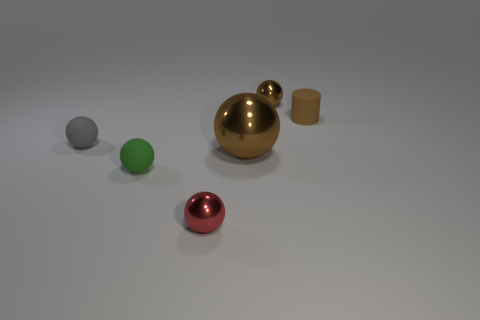Is the color of the rubber cylinder the same as the big metal sphere?
Provide a short and direct response. Yes. Is there a rubber sphere of the same color as the matte cylinder?
Give a very brief answer. No. The matte cylinder that is the same size as the red ball is what color?
Keep it short and to the point. Brown. Are there any large brown metal things that have the same shape as the small green object?
Offer a very short reply. Yes. What is the shape of the small rubber thing that is the same color as the large metal sphere?
Give a very brief answer. Cylinder. Is there a tiny ball that is on the left side of the brown shiny thing that is behind the tiny matte cylinder that is behind the gray thing?
Offer a very short reply. Yes. There is a gray object that is the same size as the green sphere; what shape is it?
Your answer should be compact. Sphere. What color is the other large metallic thing that is the same shape as the red shiny thing?
Give a very brief answer. Brown. How many objects are either big brown things or red metal balls?
Ensure brevity in your answer.  2. Does the metal object that is in front of the green matte object have the same shape as the small gray object that is in front of the small brown metal sphere?
Provide a short and direct response. Yes. 